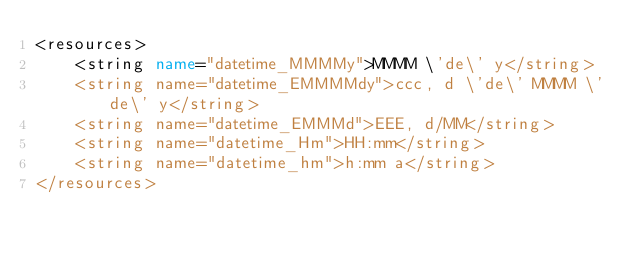Convert code to text. <code><loc_0><loc_0><loc_500><loc_500><_XML_><resources>
    <string name="datetime_MMMMy">MMMM \'de\' y</string>
    <string name="datetime_EMMMMdy">ccc, d \'de\' MMMM \'de\' y</string>
    <string name="datetime_EMMMd">EEE, d/MM</string>
    <string name="datetime_Hm">HH:mm</string>
    <string name="datetime_hm">h:mm a</string>
</resources>
</code> 